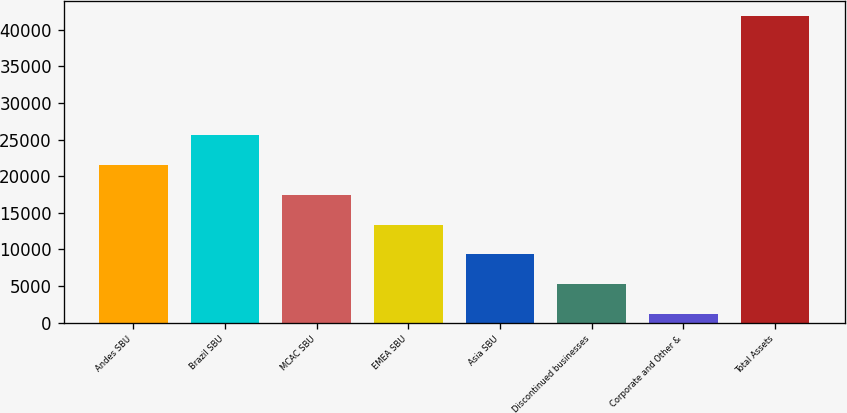Convert chart. <chart><loc_0><loc_0><loc_500><loc_500><bar_chart><fcel>Andes SBU<fcel>Brazil SBU<fcel>MCAC SBU<fcel>EMEA SBU<fcel>Asia SBU<fcel>Discontinued businesses<fcel>Corporate and Other &<fcel>Total Assets<nl><fcel>21509<fcel>25573.2<fcel>17444.8<fcel>13380.6<fcel>9316.4<fcel>5252.2<fcel>1188<fcel>41830<nl></chart> 